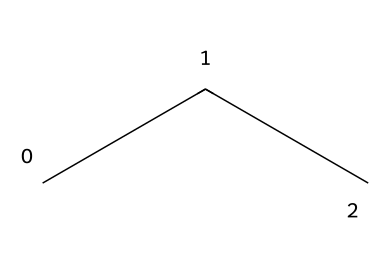What is the name of this chemical? The SMILES representation "CCC" corresponds to propane, which is a three-carbon alkane.
Answer: propane How many carbon atoms are present in this chemical? The chemical structure contains three carbon atoms as indicated by "CCC" in the SMILES notation.
Answer: three What type of bonds are present in this chemical? Propane consists of single bonds between carbon atoms (sigma bonds), which is typical for alkanes due to their saturated nature.
Answer: single bonds Is this chemical used as a refrigerant? Yes, propane is known to be used as an alternative refrigerant, commonly utilized in portable cooling units.
Answer: yes What is the general molecular formula for this type of refrigerant? The molecular formula for propane, being in the alkane category, is C3H8.
Answer: C3H8 How does the molecular arrangement of this chemical affect its boiling point? The three-dimensional arrangement of propane contributes to its molecular interactions; as a straight-chain alkane, it has a relatively low boiling point due to weak Van der Waals forces compared to larger hydrocarbons.
Answer: low boiling point Why is propane considered a preferred alternative refrigerant? Propane is considered an eco-friendly refrigerant due to its low global warming potential and efficiency in heat exchange processes.
Answer: eco-friendly 